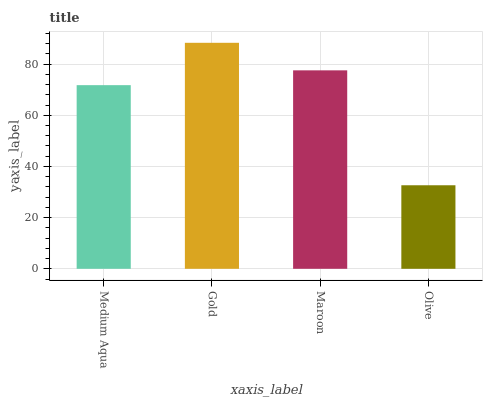Is Olive the minimum?
Answer yes or no. Yes. Is Gold the maximum?
Answer yes or no. Yes. Is Maroon the minimum?
Answer yes or no. No. Is Maroon the maximum?
Answer yes or no. No. Is Gold greater than Maroon?
Answer yes or no. Yes. Is Maroon less than Gold?
Answer yes or no. Yes. Is Maroon greater than Gold?
Answer yes or no. No. Is Gold less than Maroon?
Answer yes or no. No. Is Maroon the high median?
Answer yes or no. Yes. Is Medium Aqua the low median?
Answer yes or no. Yes. Is Gold the high median?
Answer yes or no. No. Is Maroon the low median?
Answer yes or no. No. 